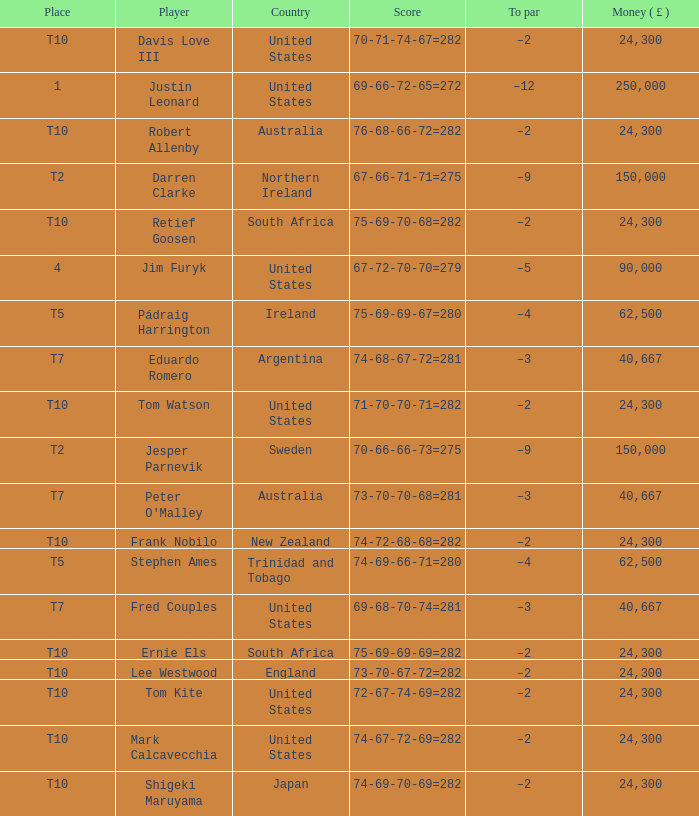How much money has been won by Stephen Ames? 62500.0. 